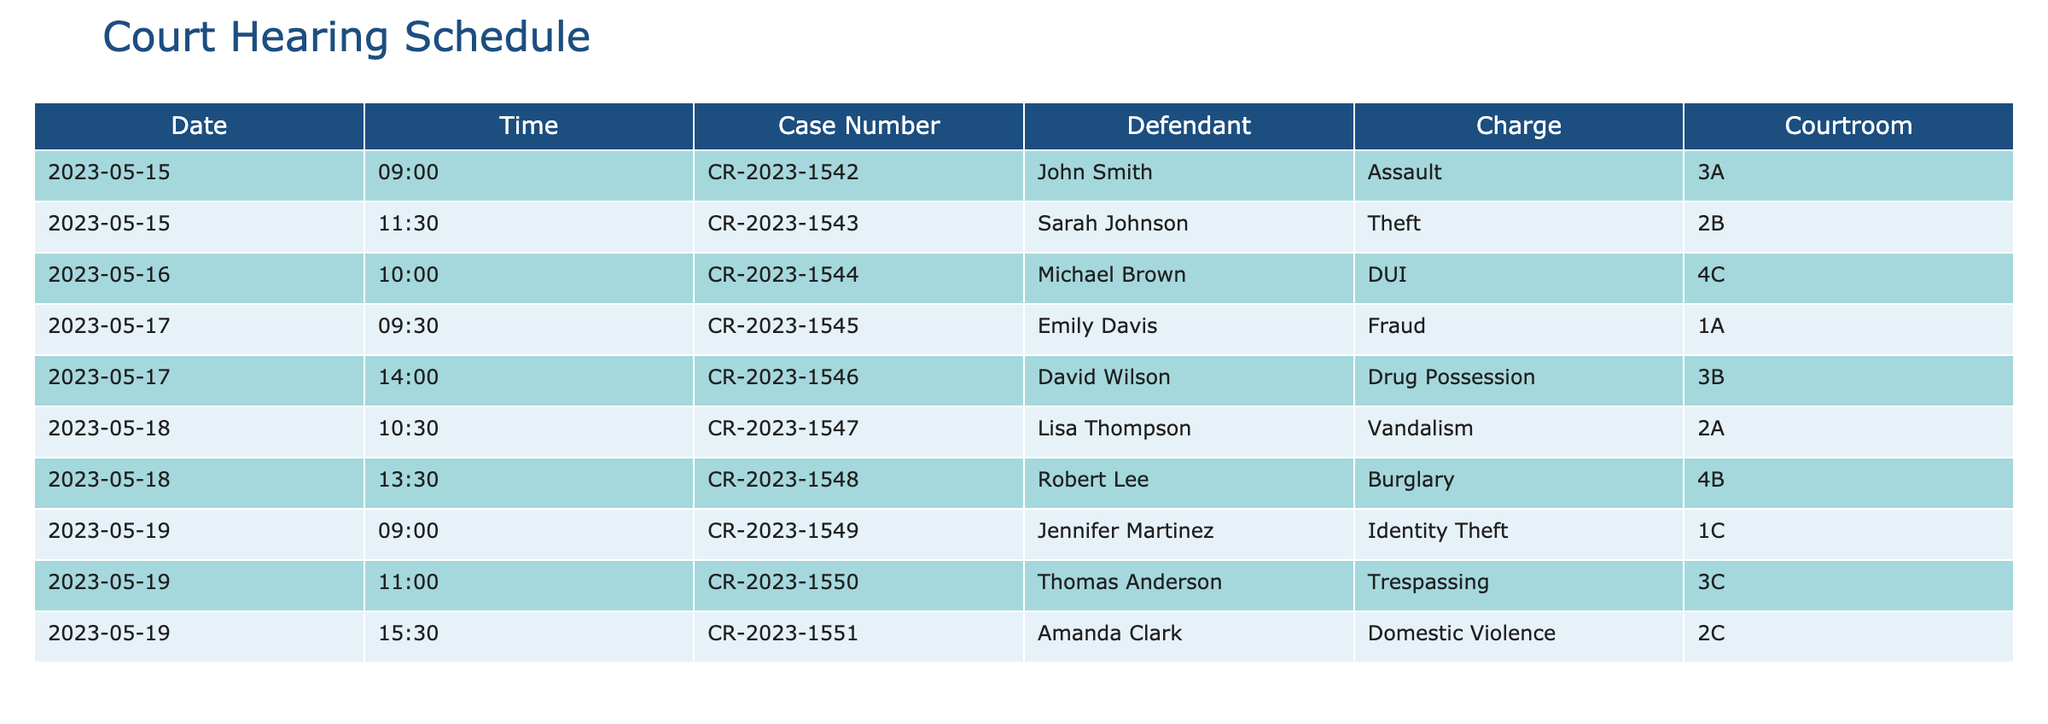What is the charge for David Wilson? According to the table, David Wilson is facing a charge of Drug Possession on the date of May 17th, 2023.
Answer: Drug Possession How many cases are scheduled for May 19th? Upon reviewing the table, there are three cases scheduled on May 19th for the defendants Jennifer Martinez, Thomas Anderson, and Amanda Clark.
Answer: 3 Which courtroom is assigned for the case of Sarah Johnson? The table provides that Sarah Johnson's case, regarding Theft, is scheduled in courtroom 2B on May 15th, 2023.
Answer: 2B Is there a case on May 16th? Yes, the table shows that there is a case scheduled on May 16th for Michael Brown with the charge of DUI.
Answer: Yes What is the difference in the number of cases scheduled between May 15th and May 18th? There are two cases on May 15th (John Smith and Sarah Johnson) and two cases on May 18th (Lisa Thompson and Robert Lee). The difference is 2 - 2 = 0.
Answer: 0 How many defendants are scheduled for non-violent charges in the upcoming week? Reviewing the charges listed, Assault, Theft, Fraud, Drug Possession, Vandalism, Burglary, Identity Theft, Trespassing, and Domestic Violence, we can categorize Theft, Fraud, Vandalism, and Trespassing as non-violent, leading to a total of five defendants: Sarah Johnson, Emily Davis, Lisa Thompson, Robert Lee, and Thomas Anderson.
Answer: 5 What is the earliest case scheduled in the upcoming week? In the table, the earliest case is for John Smith on May 15th, 2023, at 9:00 AM, as it's the first entry in the schedule.
Answer: John Smith Which defendant has the latest case scheduled and what is the charge? The latest case scheduled in the table is for Amanda Clark on May 19th, 2023, at 3:30 PM, which is for Domestic Violence. This indicates it is the last case in the week's schedule.
Answer: Amanda Clark, Domestic Violence Are there any cases for drug-related charges in the upcoming week? Yes, the table indicates there is one drug-related case for David Wilson on May 17th, 2023, charged with Drug Possession.
Answer: Yes 